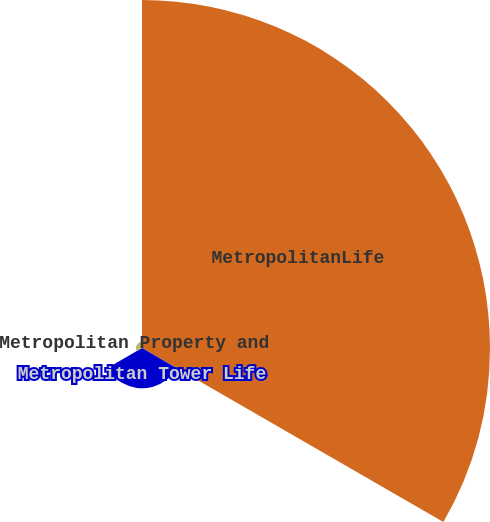Convert chart. <chart><loc_0><loc_0><loc_500><loc_500><pie_chart><fcel>MetropolitanLife<fcel>Metropolitan Tower Life<fcel>Metropolitan Property and<nl><fcel>88.26%<fcel>10.21%<fcel>1.54%<nl></chart> 